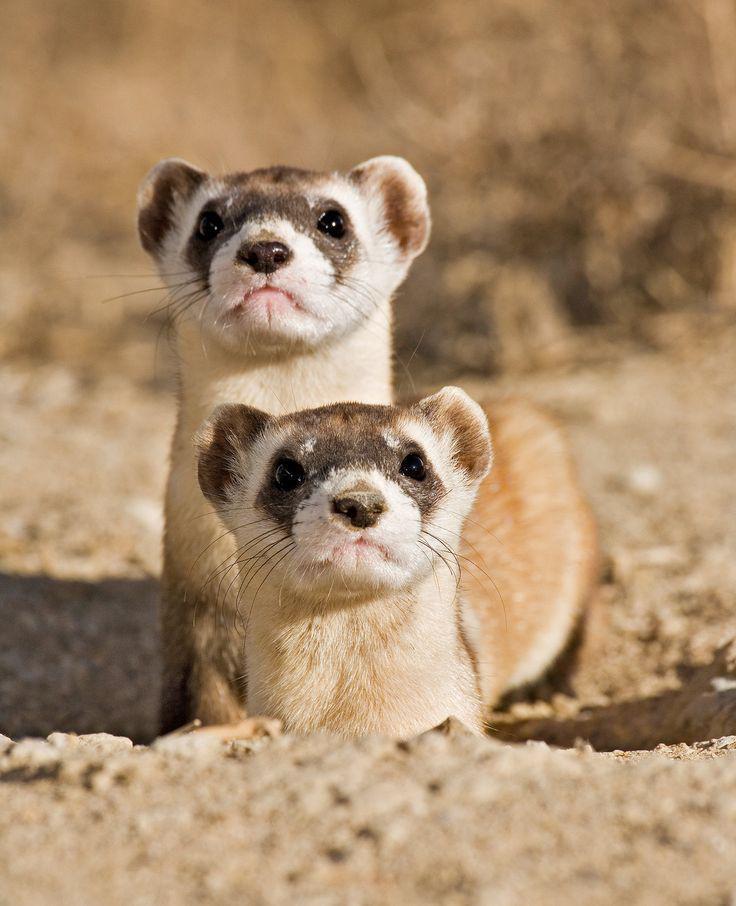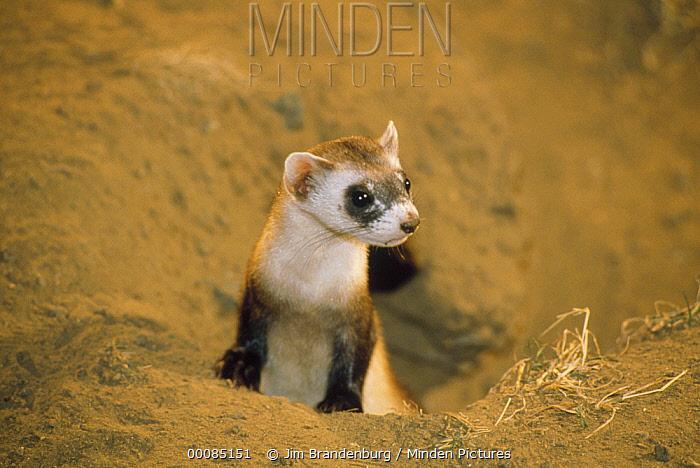The first image is the image on the left, the second image is the image on the right. Evaluate the accuracy of this statement regarding the images: "There is a pair of ferrets in one image.". Is it true? Answer yes or no. Yes. The first image is the image on the left, the second image is the image on the right. Considering the images on both sides, is "The body of at least two ferrets are facing directly at the camera" valid? Answer yes or no. Yes. 